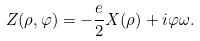<formula> <loc_0><loc_0><loc_500><loc_500>Z ( \rho , \varphi ) = - \frac { e } { 2 } X ( \rho ) + i \varphi \omega .</formula> 